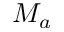<formula> <loc_0><loc_0><loc_500><loc_500>M _ { a }</formula> 